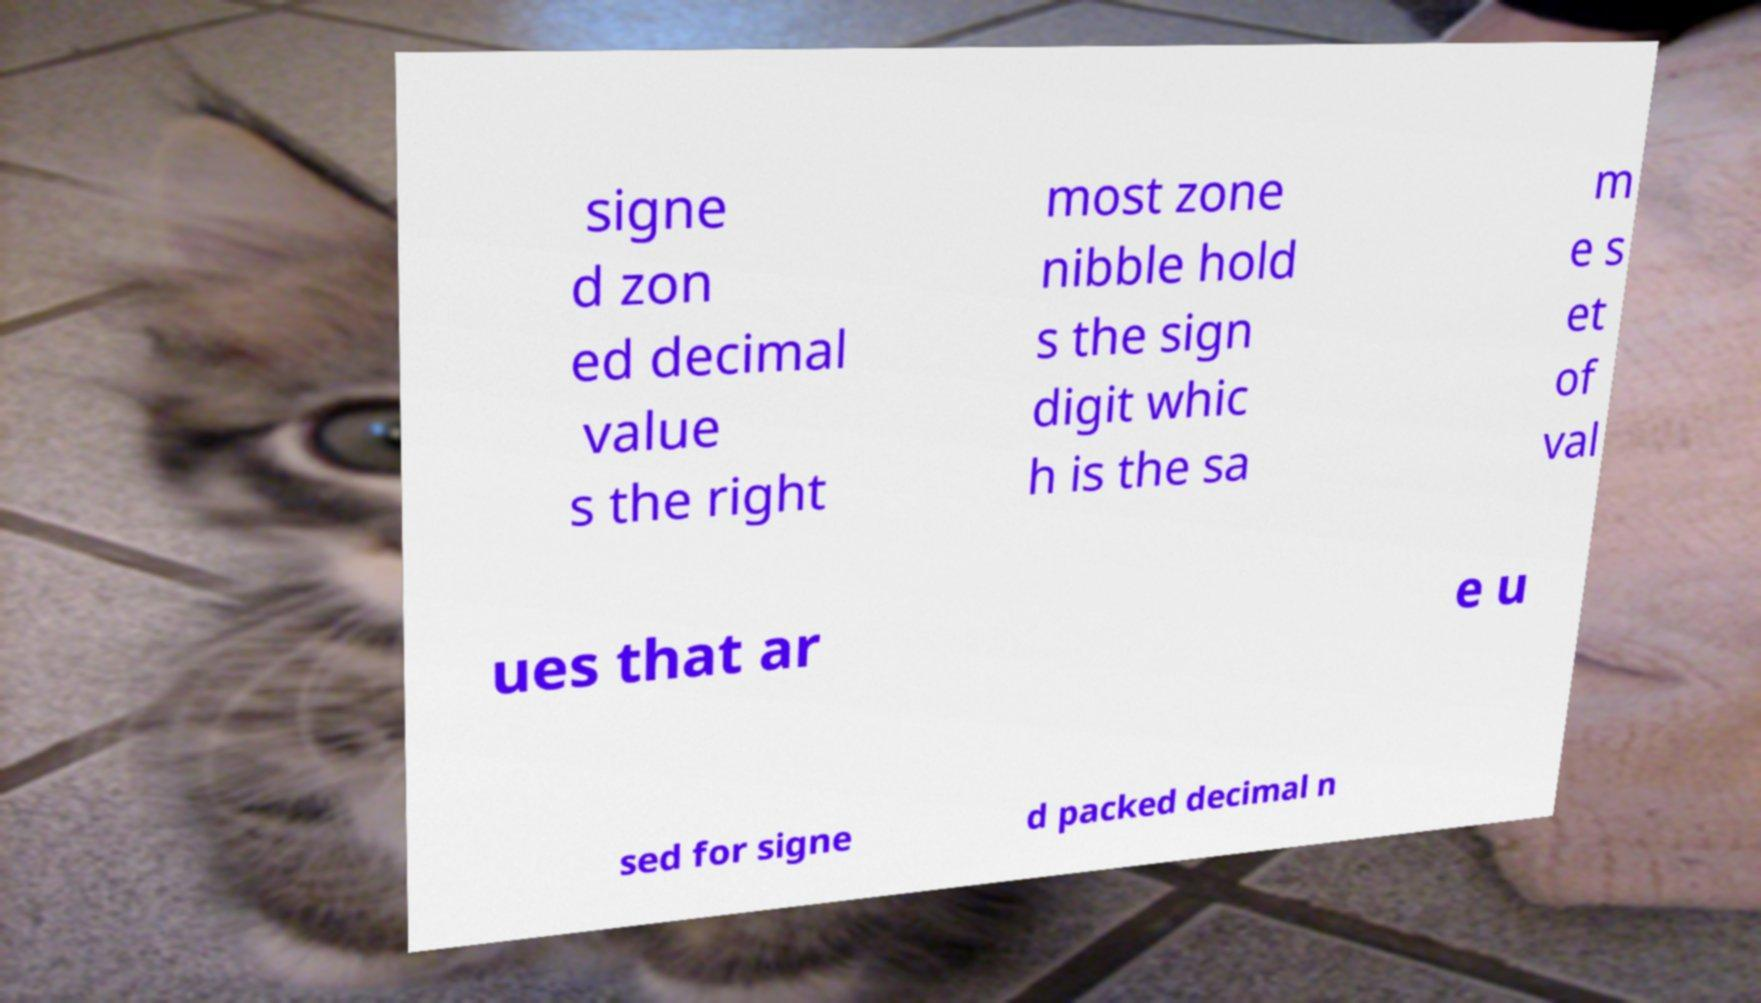Could you extract and type out the text from this image? signe d zon ed decimal value s the right most zone nibble hold s the sign digit whic h is the sa m e s et of val ues that ar e u sed for signe d packed decimal n 